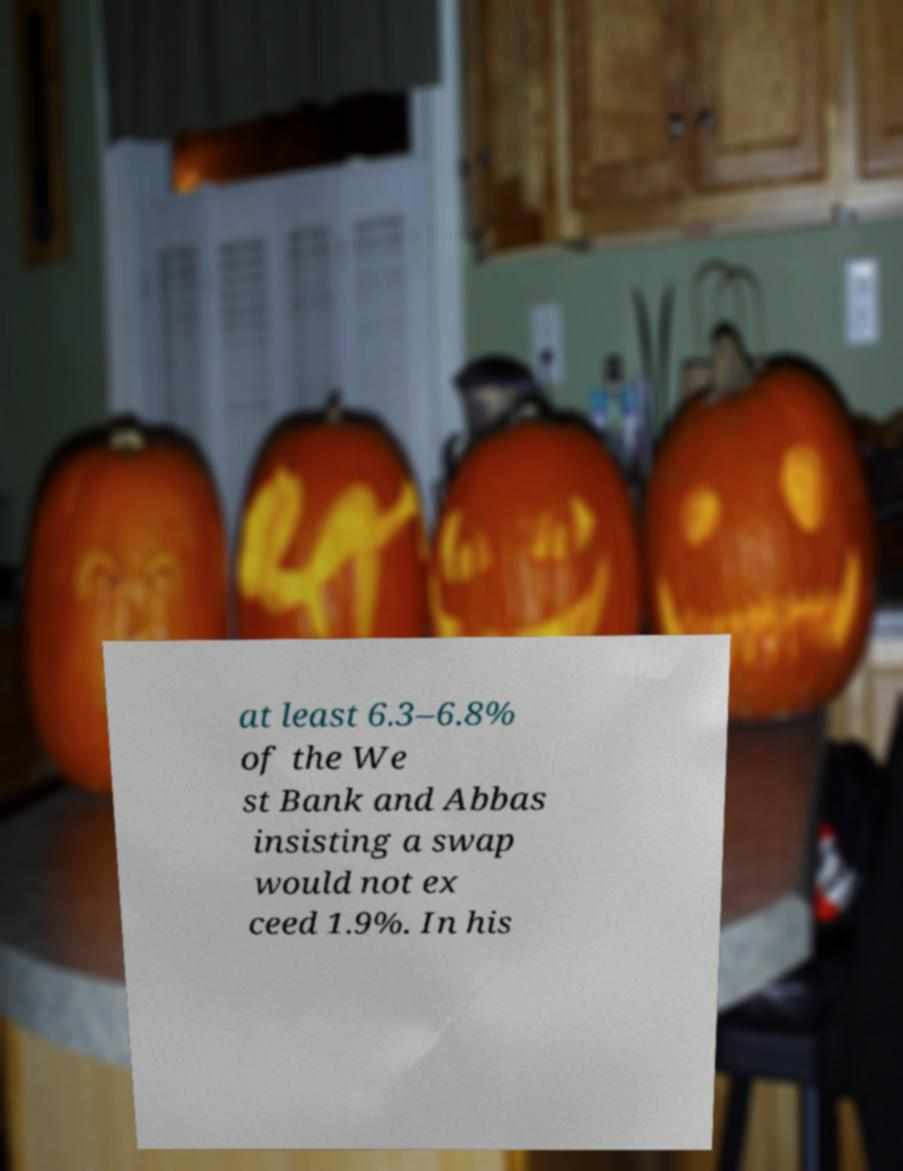Please read and relay the text visible in this image. What does it say? at least 6.3–6.8% of the We st Bank and Abbas insisting a swap would not ex ceed 1.9%. In his 